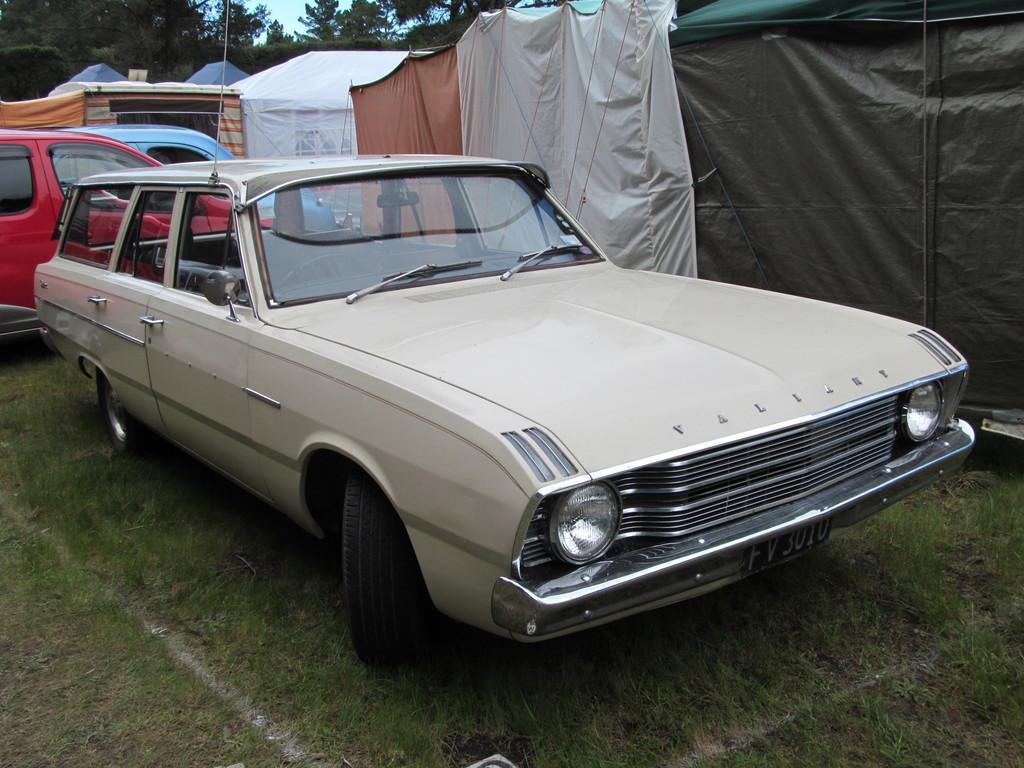Can you describe this image briefly? In the picture,there are three cars parked on the grass and beside the grass there are some tents. In the background there are few trees and sky. 